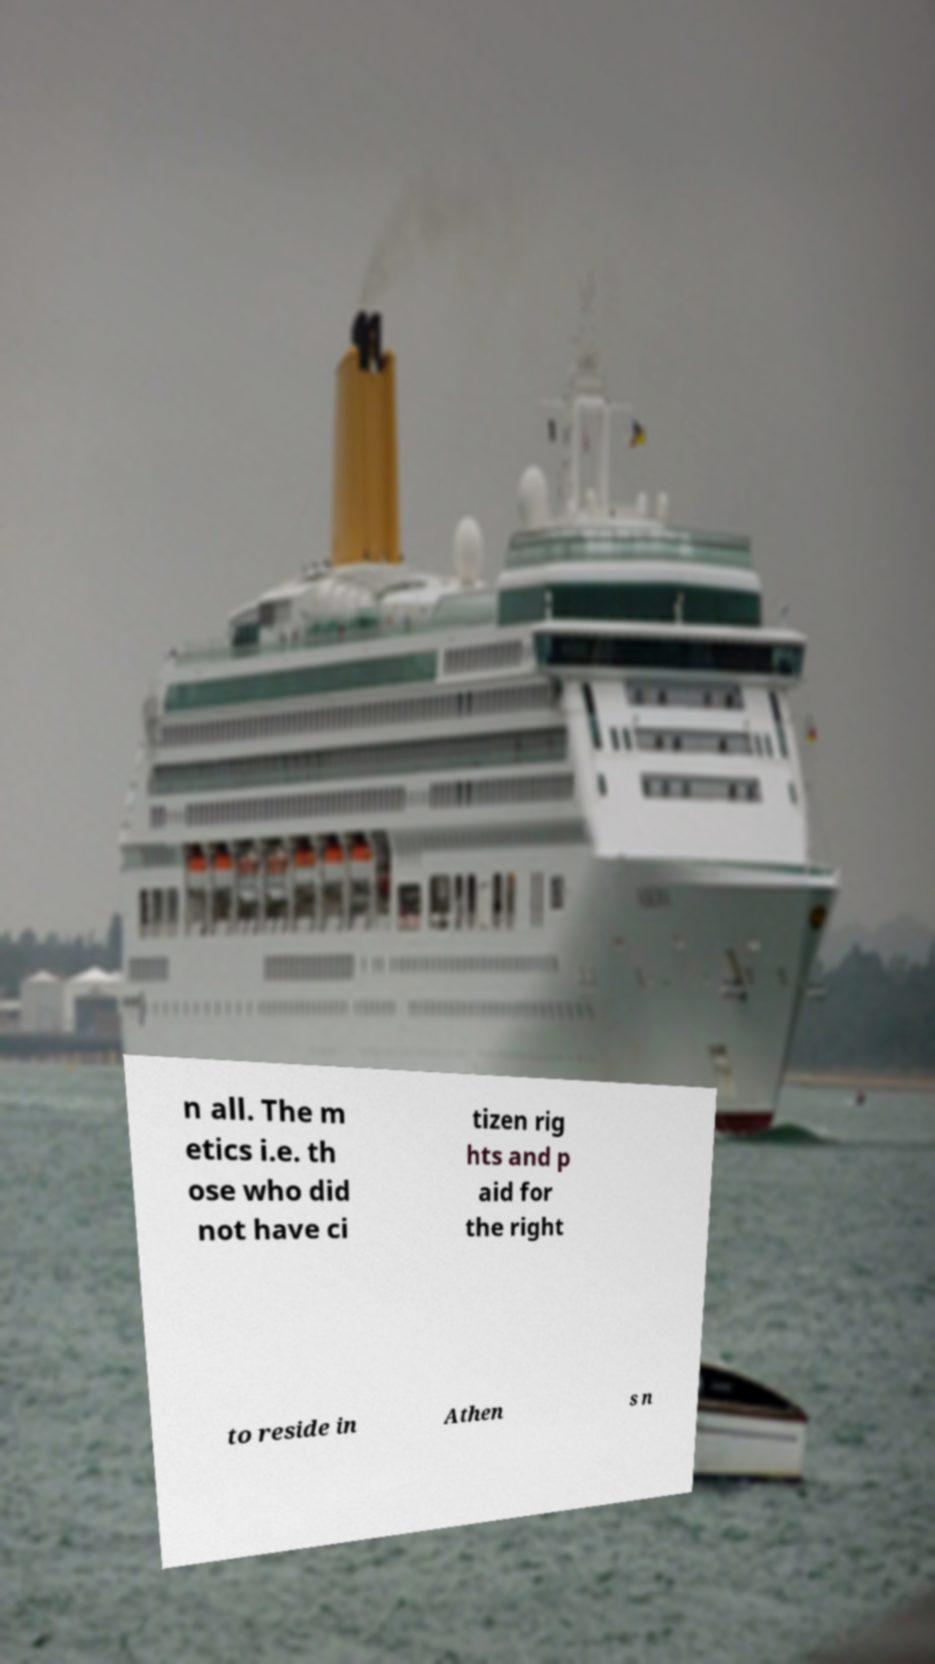For documentation purposes, I need the text within this image transcribed. Could you provide that? n all. The m etics i.e. th ose who did not have ci tizen rig hts and p aid for the right to reside in Athen s n 